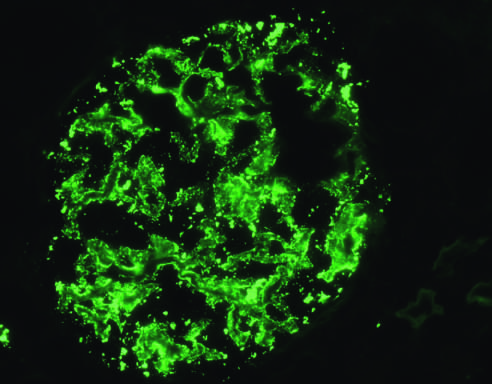s deposition of igg antibody in a granular pattern detected by immunofluorescence?
Answer the question using a single word or phrase. Yes 